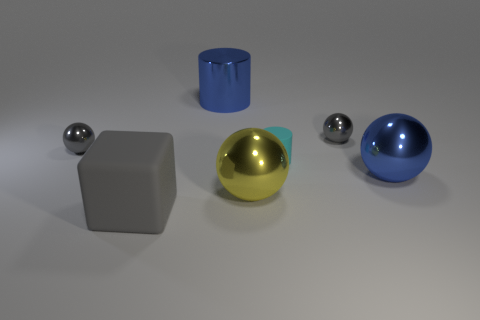How many small balls are behind the big blue shiny cylinder on the left side of the big yellow ball?
Your answer should be compact. 0. There is a yellow thing that is the same size as the gray rubber block; what is its material?
Your response must be concise. Metal. Do the small metal thing that is right of the large cube and the large gray rubber object have the same shape?
Your response must be concise. No. Are there more cyan things left of the block than blue metal cylinders to the left of the big shiny cylinder?
Provide a short and direct response. No. How many big cyan cylinders are the same material as the cube?
Your answer should be compact. 0. Is the cyan rubber object the same size as the blue metal cylinder?
Give a very brief answer. No. What color is the large cube?
Your answer should be very brief. Gray. How many objects are big yellow shiny balls or large rubber things?
Offer a very short reply. 2. Are there any blue shiny objects of the same shape as the big yellow metal object?
Make the answer very short. Yes. Is the color of the small rubber object that is to the right of the big rubber cube the same as the block?
Your answer should be very brief. No. 